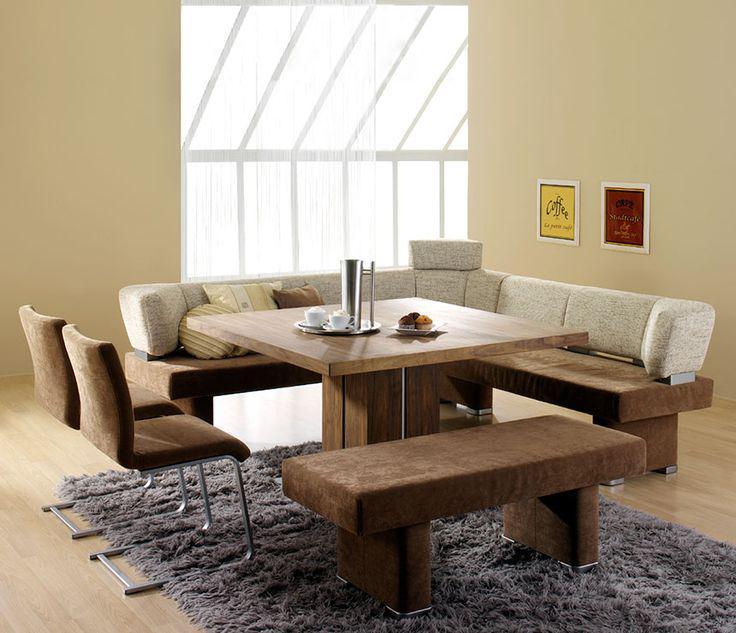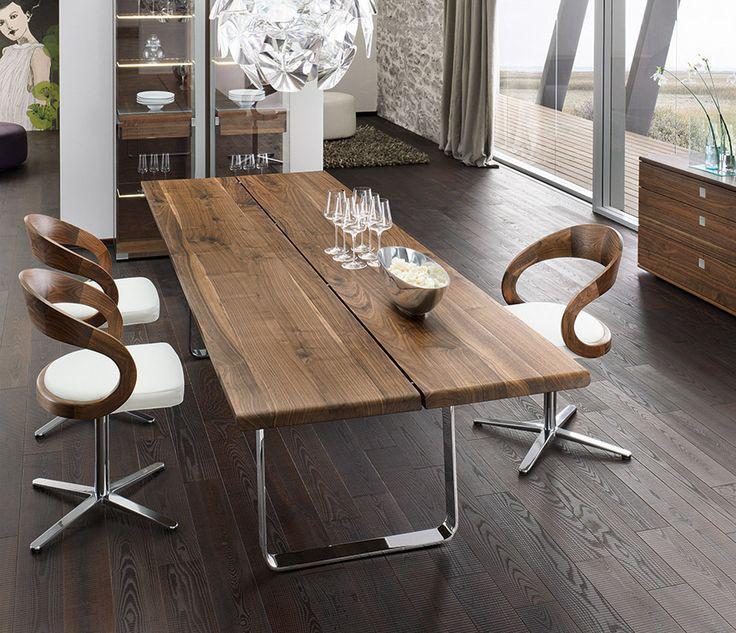The first image is the image on the left, the second image is the image on the right. For the images shown, is this caption "there is a wooden dining table with a bench as one of the seats with 3 pendent lights above the table" true? Answer yes or no. No. The first image is the image on the left, the second image is the image on the right. For the images shown, is this caption "A rectangular table has high-backed armless white chairs along the far side and a bench along the side nearest to the camera." true? Answer yes or no. No. 